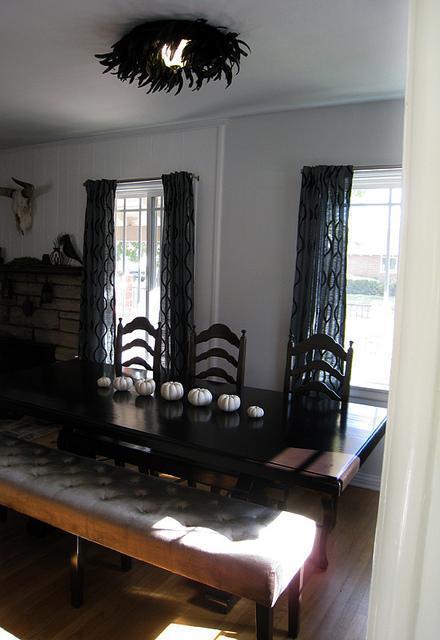How many chairs are seated at the table?
Give a very brief answer. 3. How many chairs are visible?
Give a very brief answer. 3. How many people are wearing blue jeans?
Give a very brief answer. 0. 